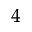<formula> <loc_0><loc_0><loc_500><loc_500>_ { 4 }</formula> 